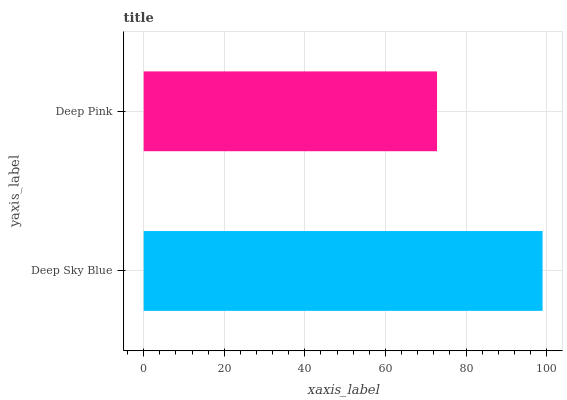Is Deep Pink the minimum?
Answer yes or no. Yes. Is Deep Sky Blue the maximum?
Answer yes or no. Yes. Is Deep Pink the maximum?
Answer yes or no. No. Is Deep Sky Blue greater than Deep Pink?
Answer yes or no. Yes. Is Deep Pink less than Deep Sky Blue?
Answer yes or no. Yes. Is Deep Pink greater than Deep Sky Blue?
Answer yes or no. No. Is Deep Sky Blue less than Deep Pink?
Answer yes or no. No. Is Deep Sky Blue the high median?
Answer yes or no. Yes. Is Deep Pink the low median?
Answer yes or no. Yes. Is Deep Pink the high median?
Answer yes or no. No. Is Deep Sky Blue the low median?
Answer yes or no. No. 